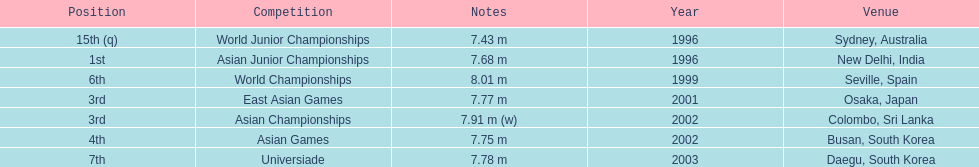Tell me the only venue in spain. Seville, Spain. 